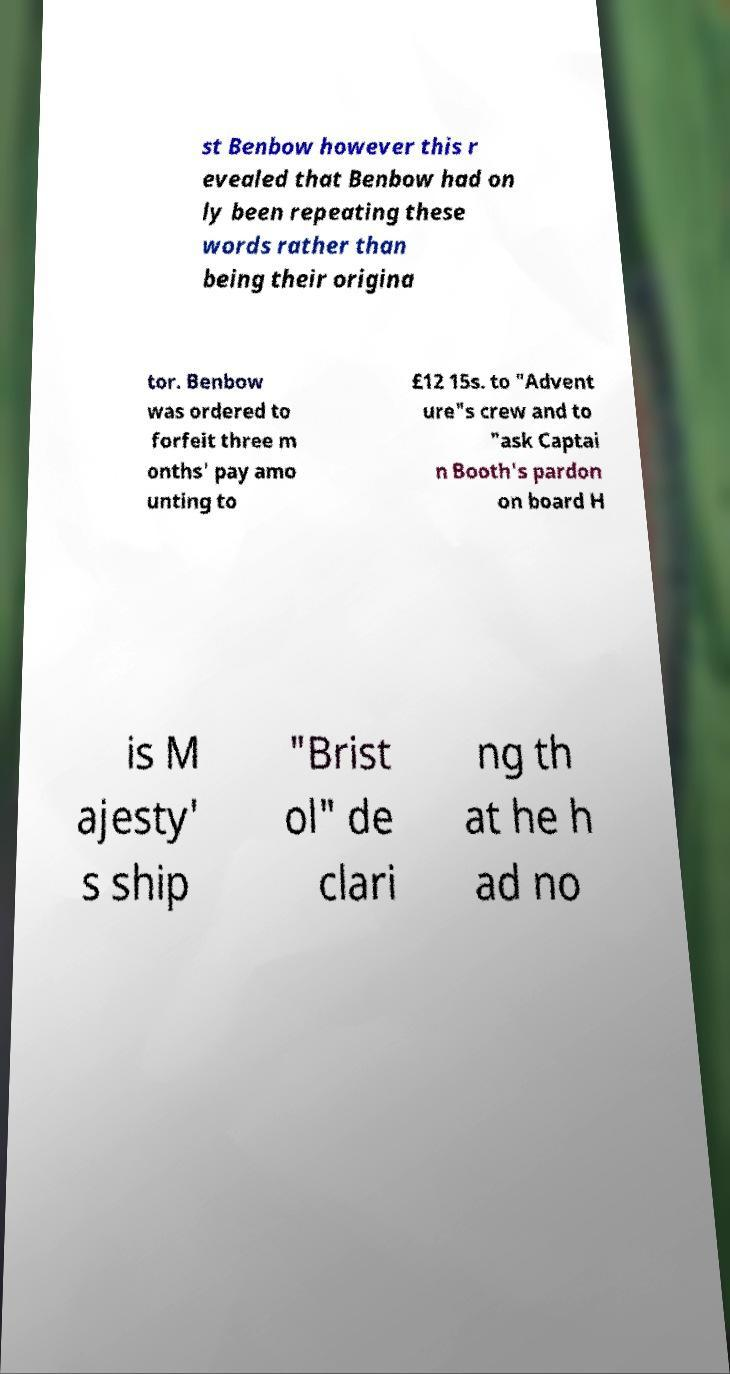Could you extract and type out the text from this image? st Benbow however this r evealed that Benbow had on ly been repeating these words rather than being their origina tor. Benbow was ordered to forfeit three m onths' pay amo unting to £12 15s. to "Advent ure"s crew and to "ask Captai n Booth's pardon on board H is M ajesty' s ship "Brist ol" de clari ng th at he h ad no 